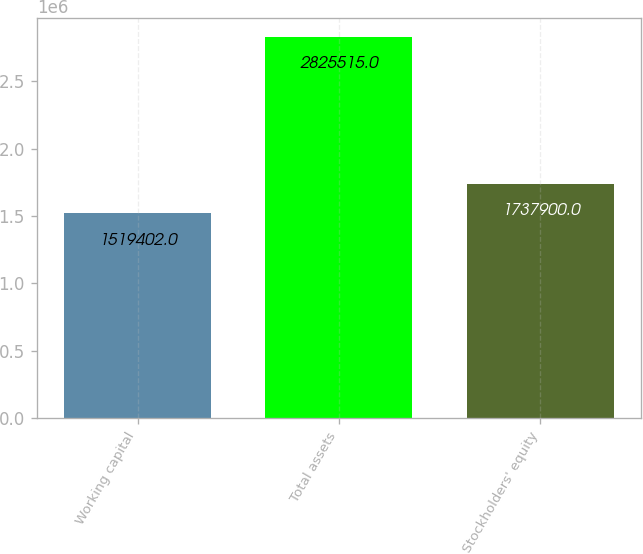Convert chart. <chart><loc_0><loc_0><loc_500><loc_500><bar_chart><fcel>Working capital<fcel>Total assets<fcel>Stockholders' equity<nl><fcel>1.5194e+06<fcel>2.82552e+06<fcel>1.7379e+06<nl></chart> 